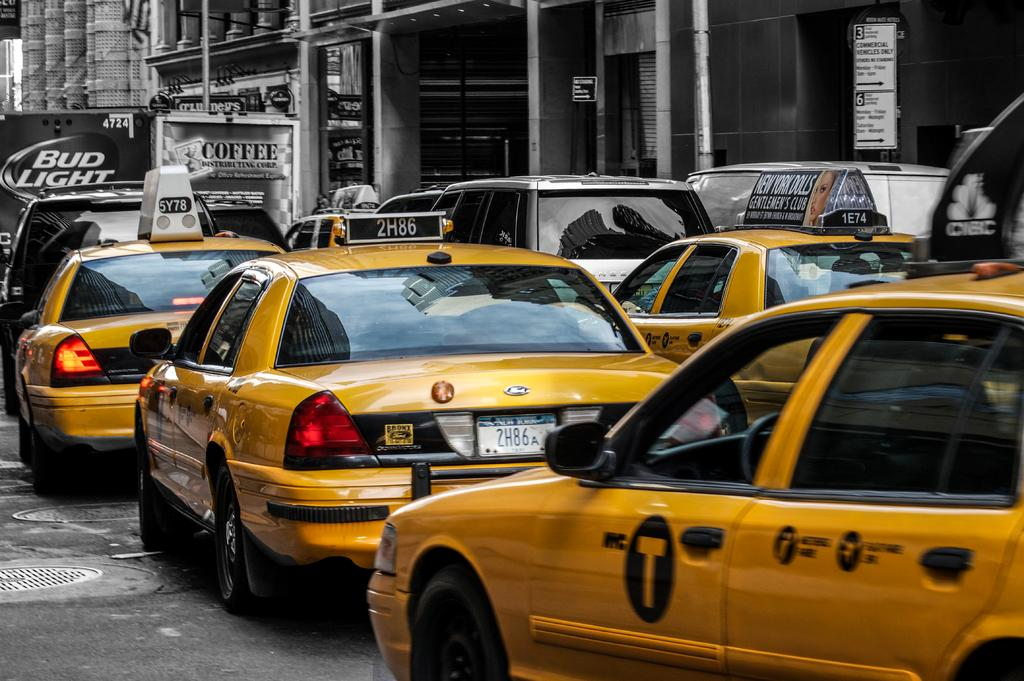<image>
Offer a succinct explanation of the picture presented. A coffee truck and Bud Light truck are next to each other in front of several taxi cabs on a busy street. 